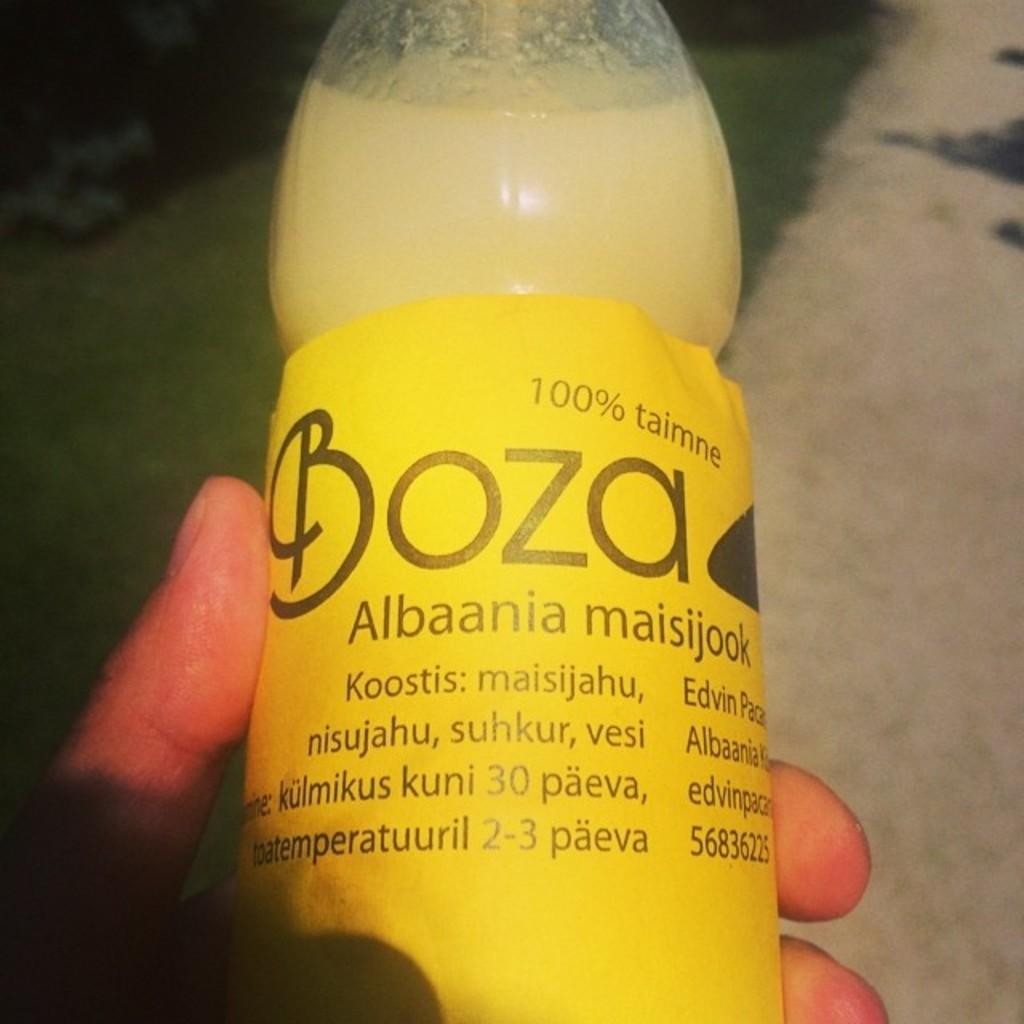What is the main subject of the image? There is a person in the image. What is the person holding in the image? The person is holding a bottle. Can you describe the bottle in the image? The bottle is yellow in color and has a label on it. What religious symbol can be seen on the person's clothing in the image? There is no religious symbol visible on the person's clothing in the image. What type of waste is being disposed of in the image? There is no waste present in the image; it features a person holding a yellow bottle with a label. 